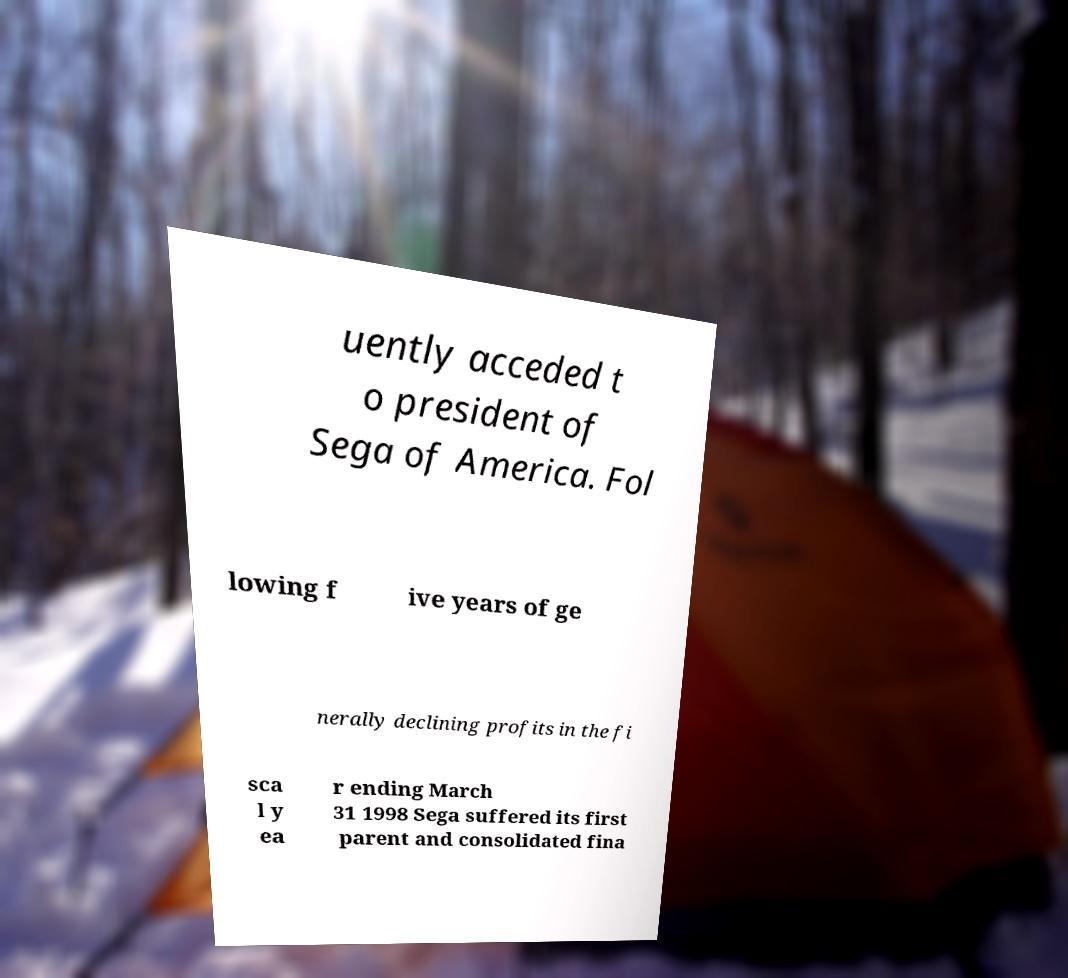Can you read and provide the text displayed in the image?This photo seems to have some interesting text. Can you extract and type it out for me? uently acceded t o president of Sega of America. Fol lowing f ive years of ge nerally declining profits in the fi sca l y ea r ending March 31 1998 Sega suffered its first parent and consolidated fina 